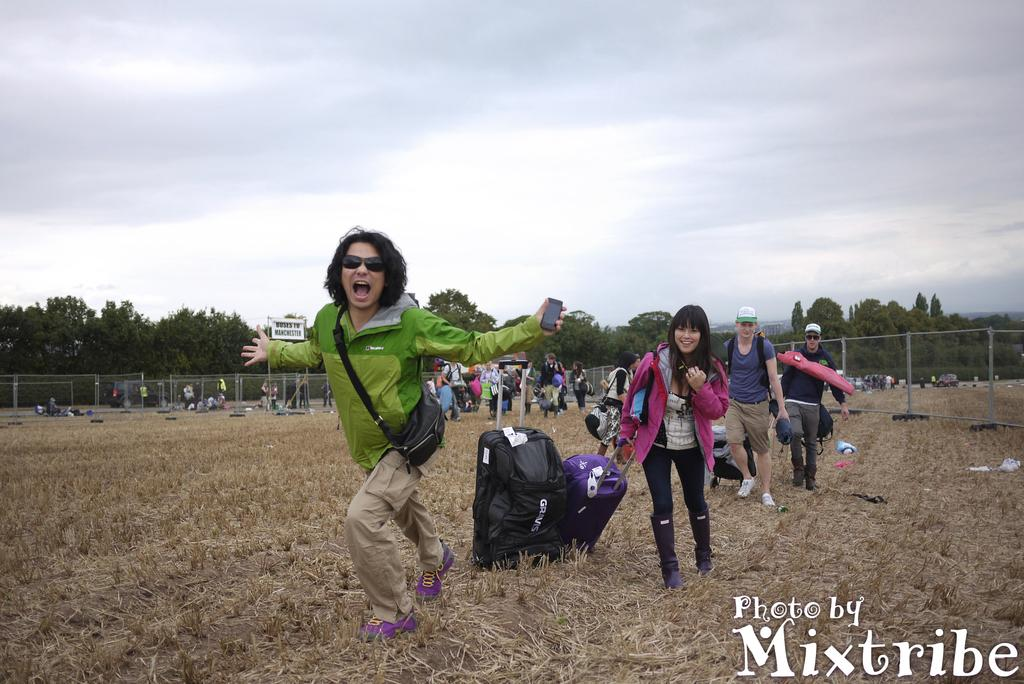What can be seen in the image? There are people standing in the image. What is the surface beneath the people's feet? The ground is visible in the image. How would you describe the condition of the ground? The ground is covered with dry grass. What can be seen in the distance behind the people? There are trees in the background of the image. What type of jeans are the cactus wearing in the image? There are no cacti or jeans present in the image. 